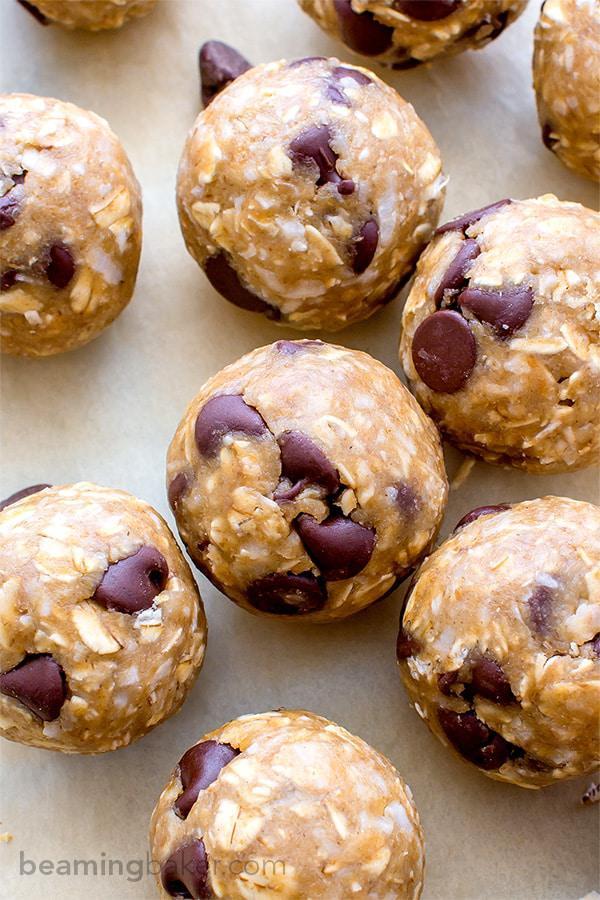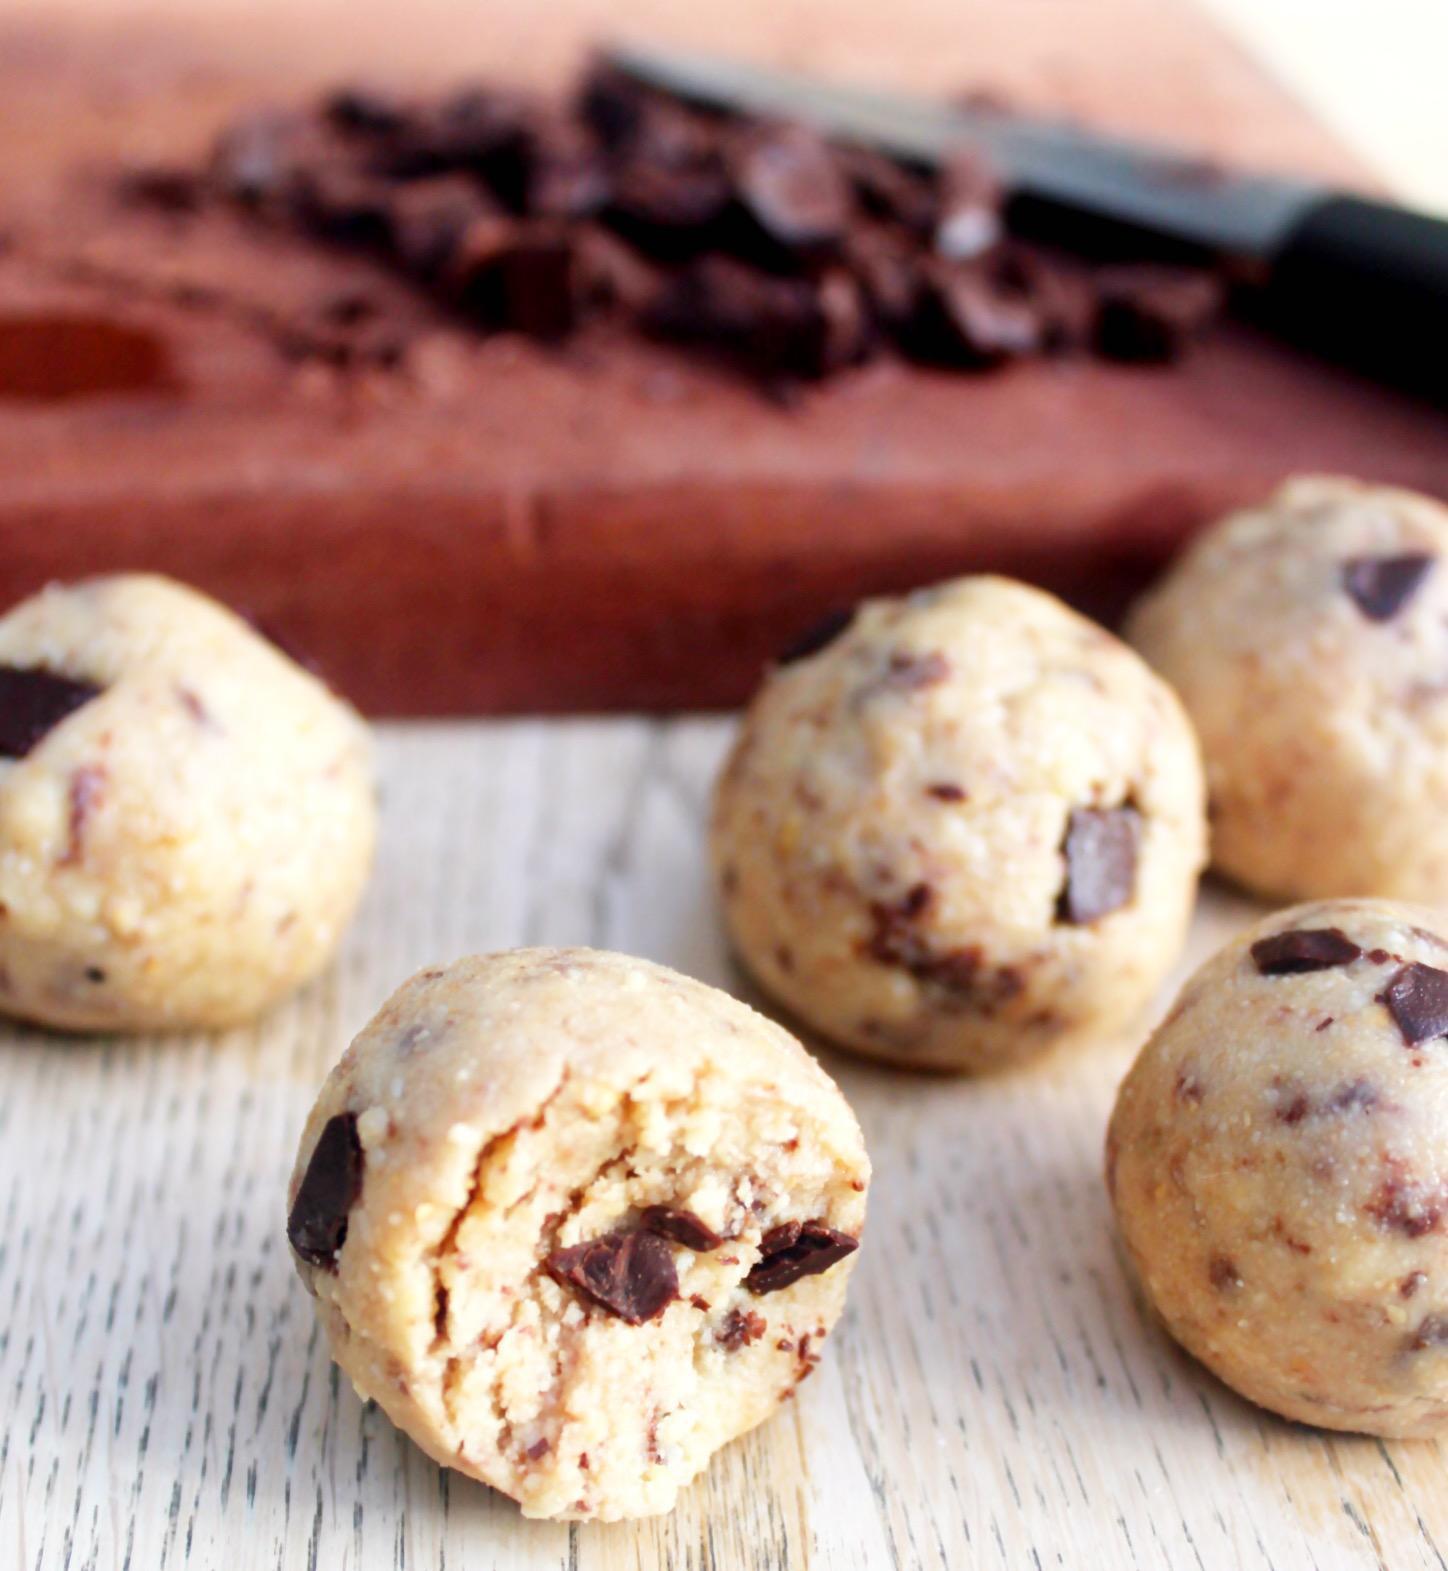The first image is the image on the left, the second image is the image on the right. Assess this claim about the two images: "Every photo shows balls of dough inside of a bowl.". Correct or not? Answer yes or no. No. The first image is the image on the left, the second image is the image on the right. Considering the images on both sides, is "The cookies in the left image are resting in a white dish." valid? Answer yes or no. No. 